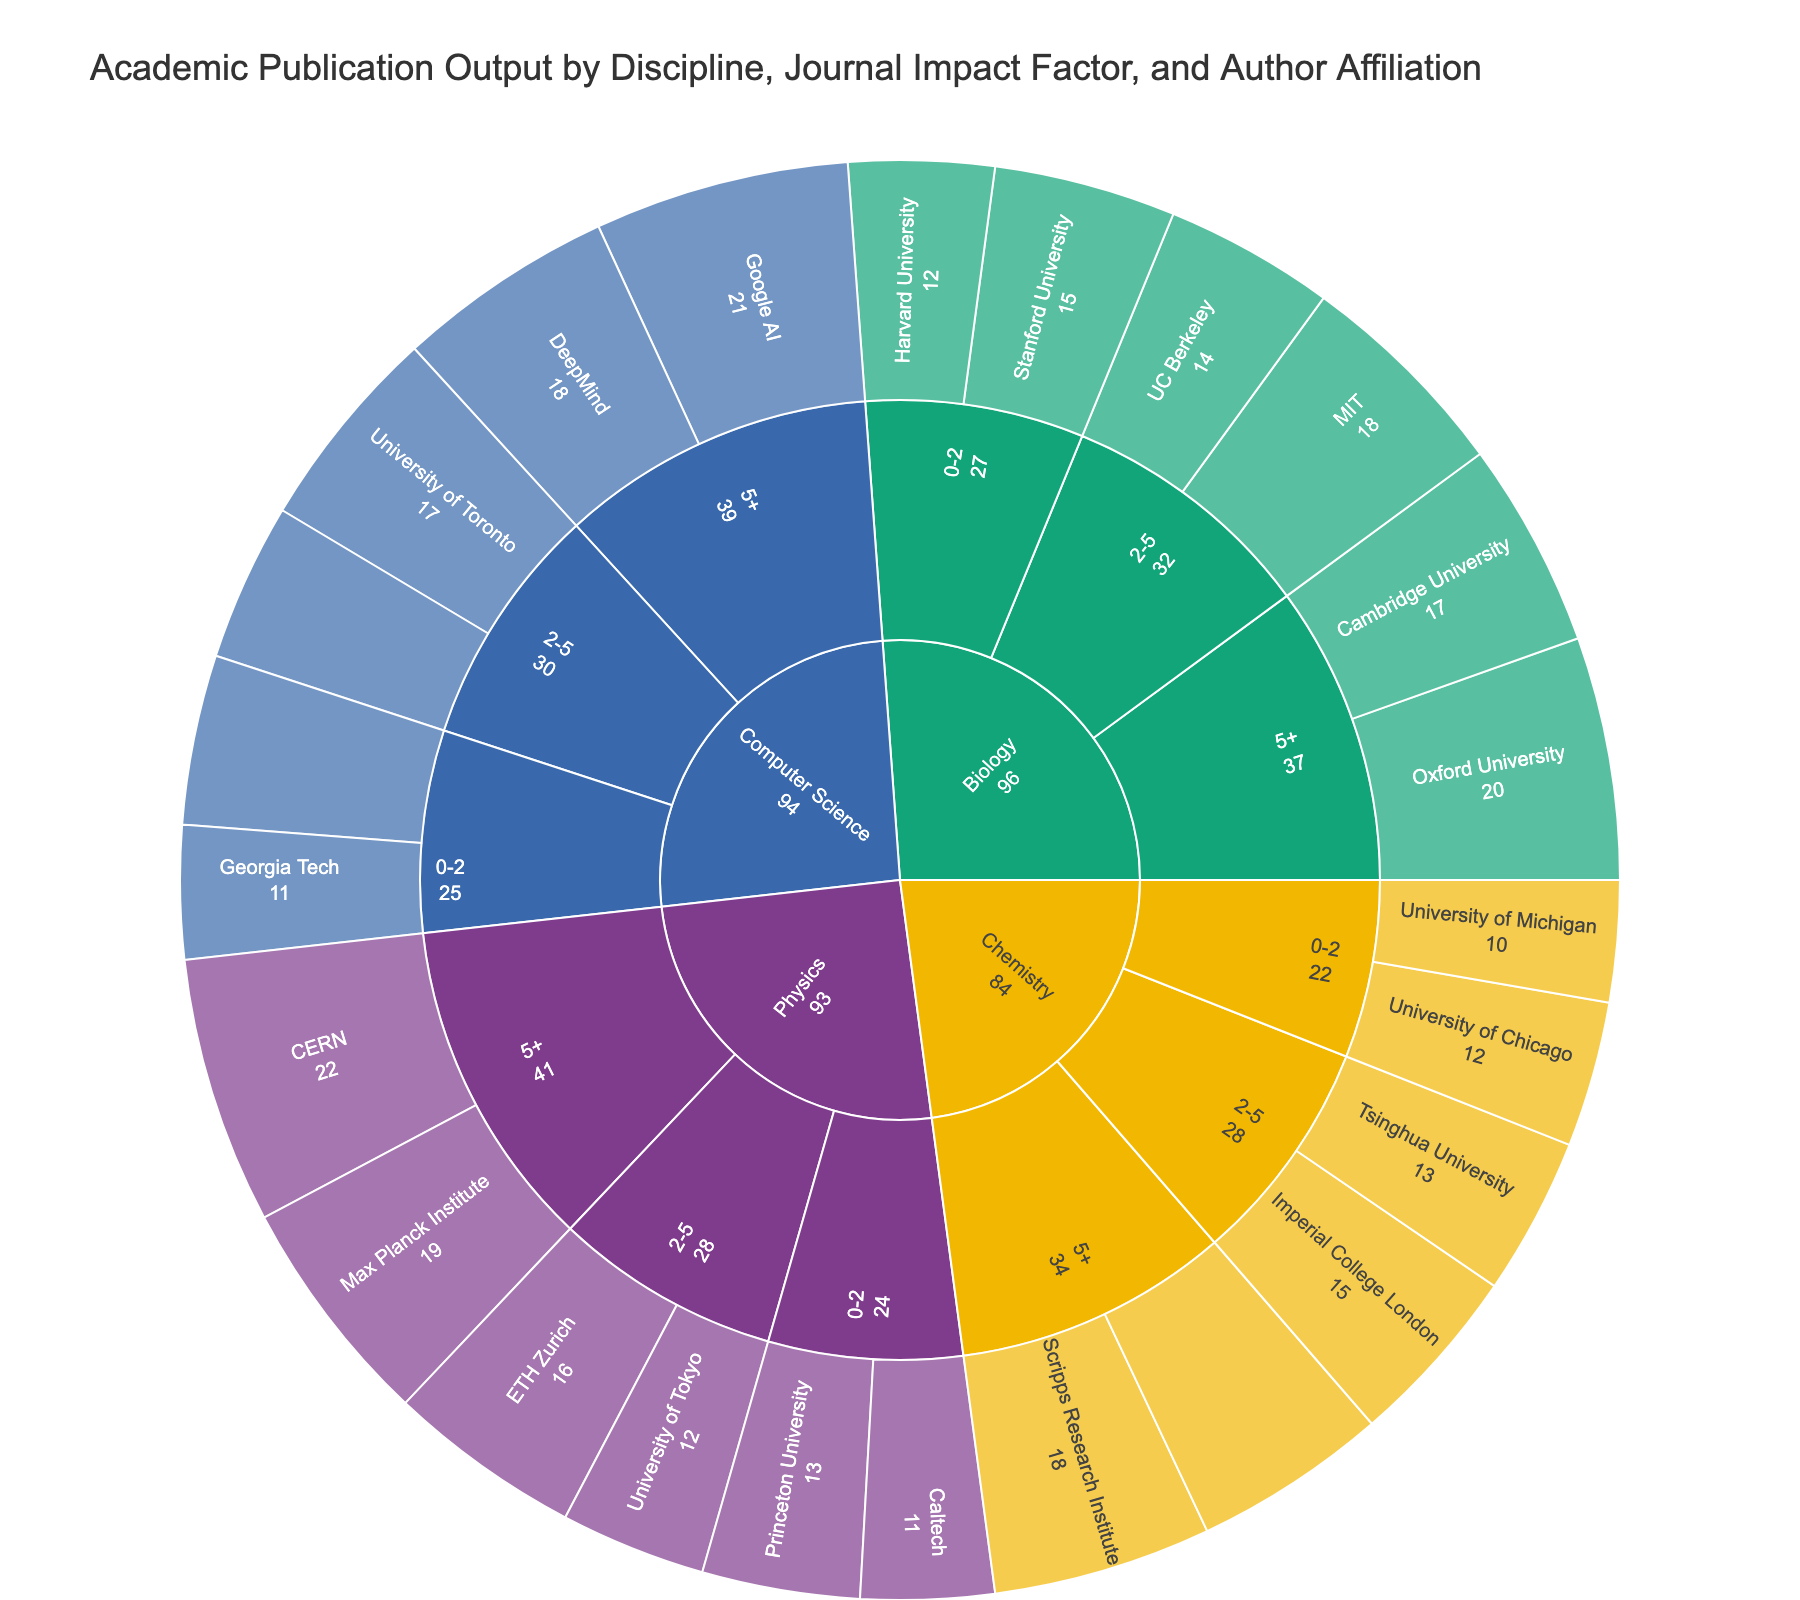What is the title of the plot? The title is often displayed at the top of the plot. Here it reads, 'Academic Publication Output by Discipline, Journal Impact Factor, and Author Affiliation'.
Answer: Academic Publication Output by Discipline, Journal Impact Factor, and Author Affiliation How many total publications are there in the Biology discipline? Sum the values for all publications under the Biology discipline which includes 15 (Stanford) + 12 (Harvard) + 18 (MIT) + 14 (UC Berkeley) + 20 (Oxford) + 17 (Cambridge) = 96.
Answer: 96 Which discipline has the highest number of publications in journals with an impact factor of 5 or higher? Count the number of publications for each discipline under the 5+ impact factor category. Physics: 19 (Max Planck Institute) + 22 (CERN) = 41, Biology: 20 (Oxford) + 17 (Cambridge) = 37, Computer Science: 21 (Google AI) + 18 (DeepMind) = 39, Chemistry: 18 (Scripps) + 16 (MPI for Chemistry) = 34. Physics has the highest.
Answer: Physics What is the total number of publications from institutions affiliated with journals in the 0-2 impact factor range? Add the publication outputs from all institutions in the 0-2 impact factor range: Biology (15+12) + Physics (11+13) + Computer Science (14+11) + Chemistry (10+12) = 103.
Answer: 103 Which institution has the highest number of publications in the Chemistry discipline? Examine the values for each institution under Chemistry. Scripps Research Institute has 18, University of Michigan has 10, University of Chicago has 12, Imperial College London has 15, Tsinghua University has 13, and Max Planck Institute for Chemistry has 16. Scripps Research Institute has the highest.
Answer: Scripps Research Institute How many disciplines contribute to the total publication count? The Sunburst Plot categorizes data based on three factors, the first one being the discipline. These disciplines are Biology, Physics, Computer Science, and Chemistry. Count these disciplines.
Answer: 4 What is the total number of publications for journals with an impact factor between 2-5 in all disciplines? Sum the values under the 2-5 impact factor category for each discipline: Biology (18 MIT + 14 UC Berkeley) + Physics (16 ETH Zurich + 12 University of Tokyo) + Computer Science (17 University of Toronto + 13 National University of Singapore) + Chemistry (15 Imperial College London + 13 Tsinghua University) = 118.
Answer: 118 In the Biology discipline, which subset of institutions has more publications: those affiliated with journals with 0-2 impact factors or those with 2-5 impact factors? Sum the publications in each impact factor range for Biology. For 0-2 impact factor: 15 (Stanford) + 12 (Harvard) = 27. For 2-5 impact factor: 18 (MIT) + 14 (UC Berkeley) = 32. Compare these sums: 32 > 27.
Answer: 2-5 impact factors Which institution in the Physics discipline with a journal impact factor of 5+ has the higher publication count? Compare the publication counts of the two institutions under Physics with a 5+ impact factor: Max Planck Institute (19) and CERN (22). CERN has the higher count.
Answer: CERN What is the difference in total publications between Computer Science and Chemistry disciplines? Sum the publication counts for each discipline, then find the difference. Computer Science: 14 (CMU) + 11 (Georgia Tech) + 17 (U of Toronto) + 13 (NUS) + 21 (Google AI) + 18 (DeepMind) = 94. Chemistry: 10 (Michigan) + 12 (Chicago) + 15 (Imperial College) + 13 (Tsinghua) + 18 (Scripps) + 16 (MPI Chemistry) = 84. Difference = 94 - 84 = 10.
Answer: 10 